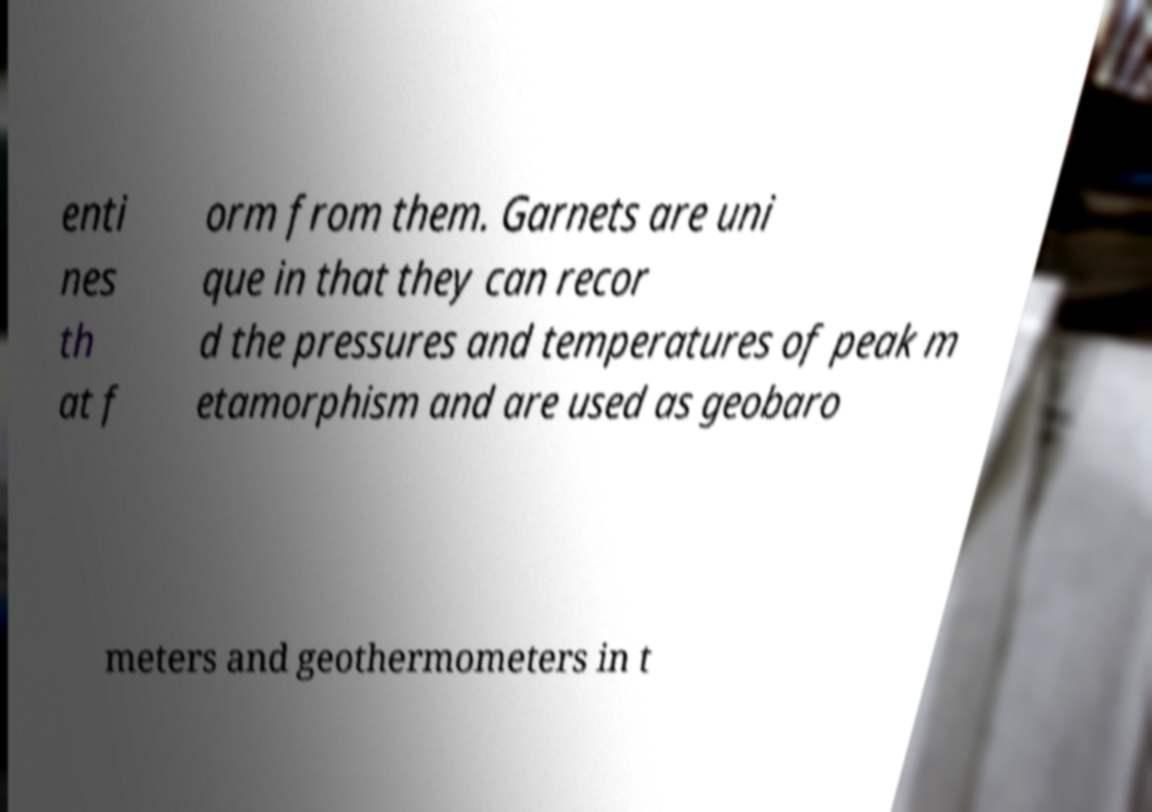There's text embedded in this image that I need extracted. Can you transcribe it verbatim? enti nes th at f orm from them. Garnets are uni que in that they can recor d the pressures and temperatures of peak m etamorphism and are used as geobaro meters and geothermometers in t 